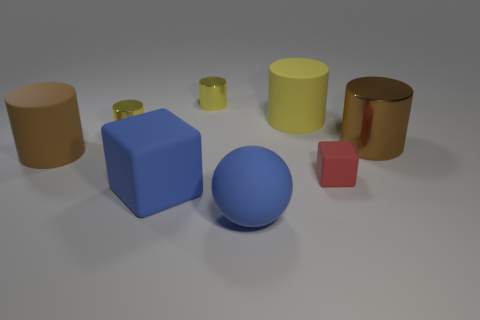There is a tiny thing that is the same material as the big block; what shape is it?
Your answer should be very brief. Cube. There is a yellow thing that is behind the big yellow matte thing; is its size the same as the block that is in front of the tiny matte cube?
Offer a terse response. No. Are there more brown objects on the right side of the blue matte sphere than red rubber blocks on the right side of the brown metal cylinder?
Provide a succinct answer. Yes. How many other things are there of the same color as the big rubber ball?
Make the answer very short. 1. There is a large metal object; is it the same color as the large object in front of the big cube?
Provide a succinct answer. No. What number of red objects are on the left side of the brown object left of the matte sphere?
Provide a succinct answer. 0. Is there any other thing that has the same material as the large cube?
Ensure brevity in your answer.  Yes. What is the brown cylinder to the right of the brown cylinder in front of the large brown object that is on the right side of the red matte cube made of?
Offer a terse response. Metal. There is a big cylinder that is both right of the large brown matte cylinder and in front of the yellow rubber thing; what material is it?
Make the answer very short. Metal. What number of yellow objects have the same shape as the red rubber object?
Provide a short and direct response. 0. 